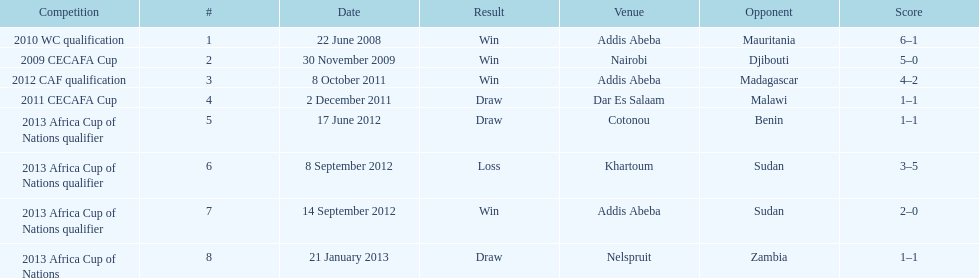What date gives was their only loss? 8 September 2012. 